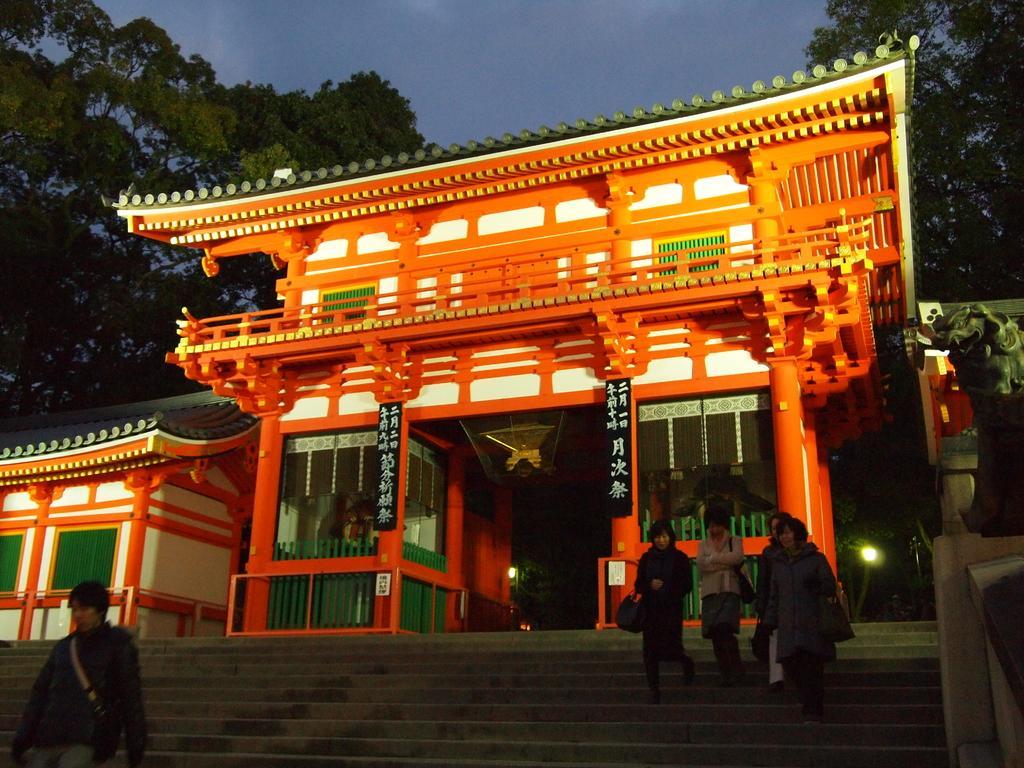In one or two sentences, can you explain what this image depicts? In this image we can see houses. In front of the houses we can see the stairs and persons walking on stairs. The persons are carrying objects. Behind the houses we can see the trees. At the top we can see the sky. On the right side, we can see a wall. 